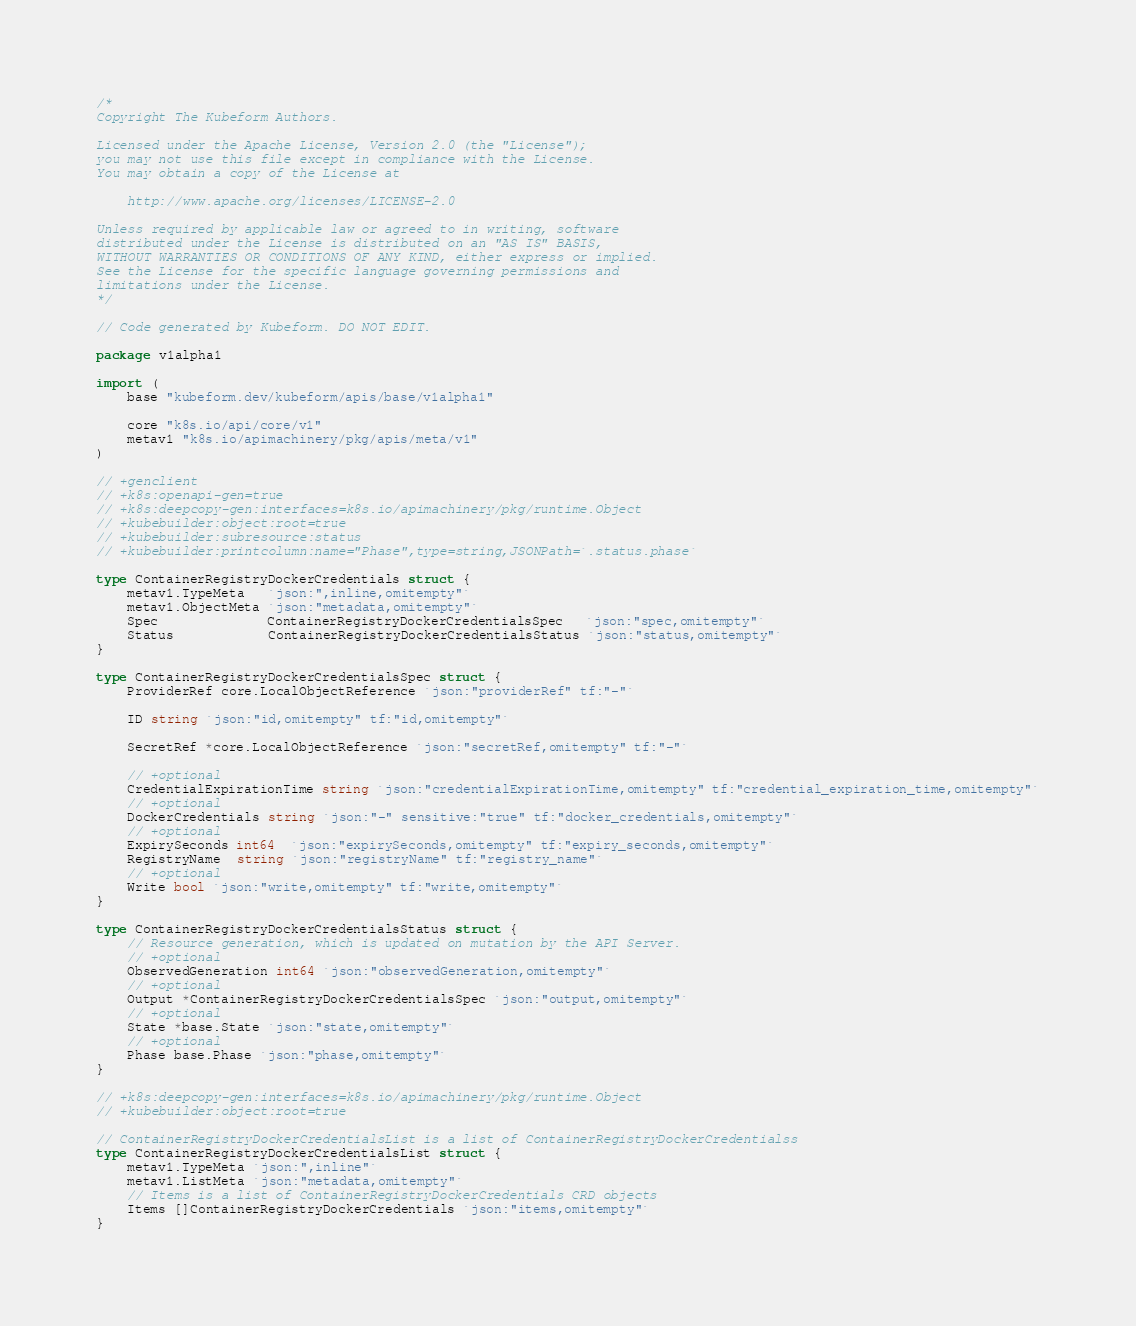Convert code to text. <code><loc_0><loc_0><loc_500><loc_500><_Go_>/*
Copyright The Kubeform Authors.

Licensed under the Apache License, Version 2.0 (the "License");
you may not use this file except in compliance with the License.
You may obtain a copy of the License at

    http://www.apache.org/licenses/LICENSE-2.0

Unless required by applicable law or agreed to in writing, software
distributed under the License is distributed on an "AS IS" BASIS,
WITHOUT WARRANTIES OR CONDITIONS OF ANY KIND, either express or implied.
See the License for the specific language governing permissions and
limitations under the License.
*/

// Code generated by Kubeform. DO NOT EDIT.

package v1alpha1

import (
	base "kubeform.dev/kubeform/apis/base/v1alpha1"

	core "k8s.io/api/core/v1"
	metav1 "k8s.io/apimachinery/pkg/apis/meta/v1"
)

// +genclient
// +k8s:openapi-gen=true
// +k8s:deepcopy-gen:interfaces=k8s.io/apimachinery/pkg/runtime.Object
// +kubebuilder:object:root=true
// +kubebuilder:subresource:status
// +kubebuilder:printcolumn:name="Phase",type=string,JSONPath=`.status.phase`

type ContainerRegistryDockerCredentials struct {
	metav1.TypeMeta   `json:",inline,omitempty"`
	metav1.ObjectMeta `json:"metadata,omitempty"`
	Spec              ContainerRegistryDockerCredentialsSpec   `json:"spec,omitempty"`
	Status            ContainerRegistryDockerCredentialsStatus `json:"status,omitempty"`
}

type ContainerRegistryDockerCredentialsSpec struct {
	ProviderRef core.LocalObjectReference `json:"providerRef" tf:"-"`

	ID string `json:"id,omitempty" tf:"id,omitempty"`

	SecretRef *core.LocalObjectReference `json:"secretRef,omitempty" tf:"-"`

	// +optional
	CredentialExpirationTime string `json:"credentialExpirationTime,omitempty" tf:"credential_expiration_time,omitempty"`
	// +optional
	DockerCredentials string `json:"-" sensitive:"true" tf:"docker_credentials,omitempty"`
	// +optional
	ExpirySeconds int64  `json:"expirySeconds,omitempty" tf:"expiry_seconds,omitempty"`
	RegistryName  string `json:"registryName" tf:"registry_name"`
	// +optional
	Write bool `json:"write,omitempty" tf:"write,omitempty"`
}

type ContainerRegistryDockerCredentialsStatus struct {
	// Resource generation, which is updated on mutation by the API Server.
	// +optional
	ObservedGeneration int64 `json:"observedGeneration,omitempty"`
	// +optional
	Output *ContainerRegistryDockerCredentialsSpec `json:"output,omitempty"`
	// +optional
	State *base.State `json:"state,omitempty"`
	// +optional
	Phase base.Phase `json:"phase,omitempty"`
}

// +k8s:deepcopy-gen:interfaces=k8s.io/apimachinery/pkg/runtime.Object
// +kubebuilder:object:root=true

// ContainerRegistryDockerCredentialsList is a list of ContainerRegistryDockerCredentialss
type ContainerRegistryDockerCredentialsList struct {
	metav1.TypeMeta `json:",inline"`
	metav1.ListMeta `json:"metadata,omitempty"`
	// Items is a list of ContainerRegistryDockerCredentials CRD objects
	Items []ContainerRegistryDockerCredentials `json:"items,omitempty"`
}
</code> 